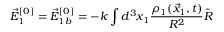<formula> <loc_0><loc_0><loc_500><loc_500>\vec { E } _ { 1 } ^ { [ 0 ] } = \vec { E } _ { 1 b } ^ { [ 0 ] } = - k \int d ^ { 3 } x _ { 1 } \frac { \rho _ { 1 } ( \vec { x } _ { 1 } , t ) } { R ^ { 2 } } \hat { R }</formula> 